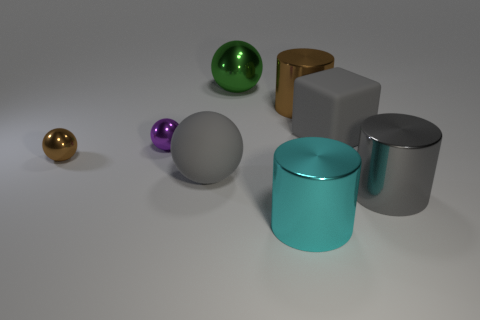The large metal thing that is the same shape as the small purple thing is what color?
Your answer should be compact. Green. There is a big gray matte object that is behind the large ball in front of the gray rubber thing that is behind the small brown object; what is its shape?
Offer a very short reply. Cube. What size is the thing that is behind the purple shiny object and right of the large brown metallic object?
Your response must be concise. Large. Is the number of cyan metal cylinders less than the number of large gray metal cubes?
Your answer should be compact. No. There is a cylinder in front of the gray metal thing; what size is it?
Your response must be concise. Large. The large metal thing that is both left of the brown shiny cylinder and behind the cyan metal thing has what shape?
Offer a terse response. Sphere. There is a cyan metal thing that is the same shape as the large brown object; what is its size?
Give a very brief answer. Large. How many large balls are the same material as the purple object?
Your response must be concise. 1. There is a block; is it the same color as the rubber object on the left side of the cyan metallic thing?
Provide a succinct answer. Yes. Is the number of tiny brown things greater than the number of objects?
Ensure brevity in your answer.  No. 